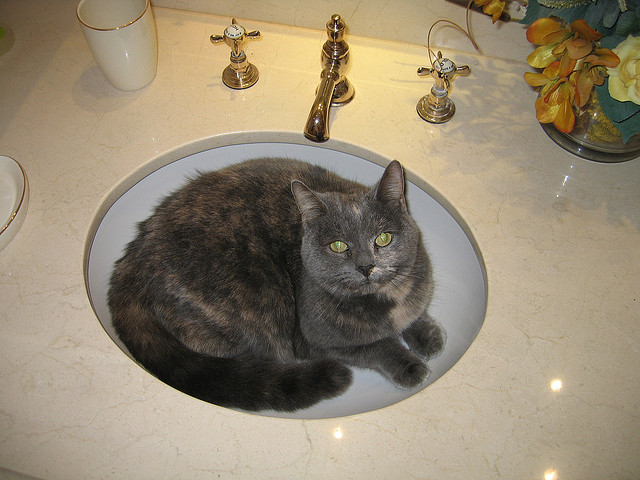Could the cat’s presence in the sink indicate a behavioral issue? Not necessarily. Cats often choose unconventional places to rest or hide, which can be driven by their natural instincts. If the cat seems healthy and isn't displaying other signs of stress or behavioral issues, it might simply enjoy the sink's shape and temperature. How can one ensure the cat's safety if it prefers places like the sink? To ensure the cat's safety, one should make sure that the sink is clear of any hazardous substances, keep the drain closed to prevent any paws from getting stuck, and always check the sink before using it to avoid startling or harming the cat. 